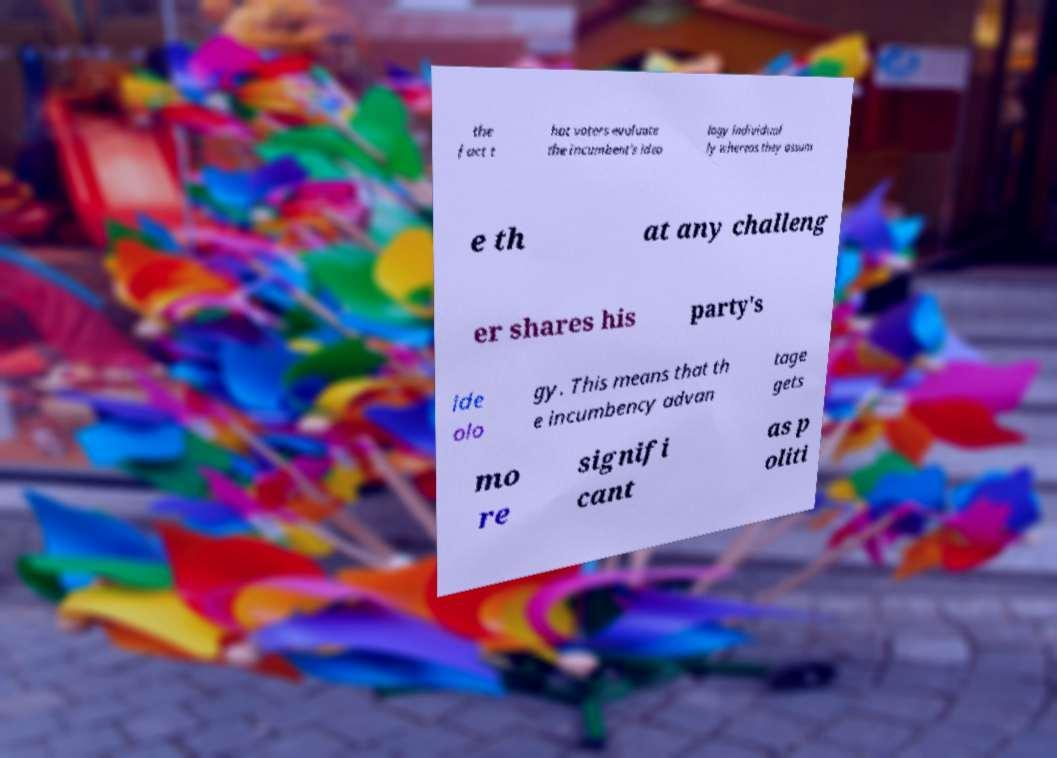Please read and relay the text visible in this image. What does it say? the fact t hat voters evaluate the incumbent's ideo logy individual ly whereas they assum e th at any challeng er shares his party's ide olo gy. This means that th e incumbency advan tage gets mo re signifi cant as p oliti 